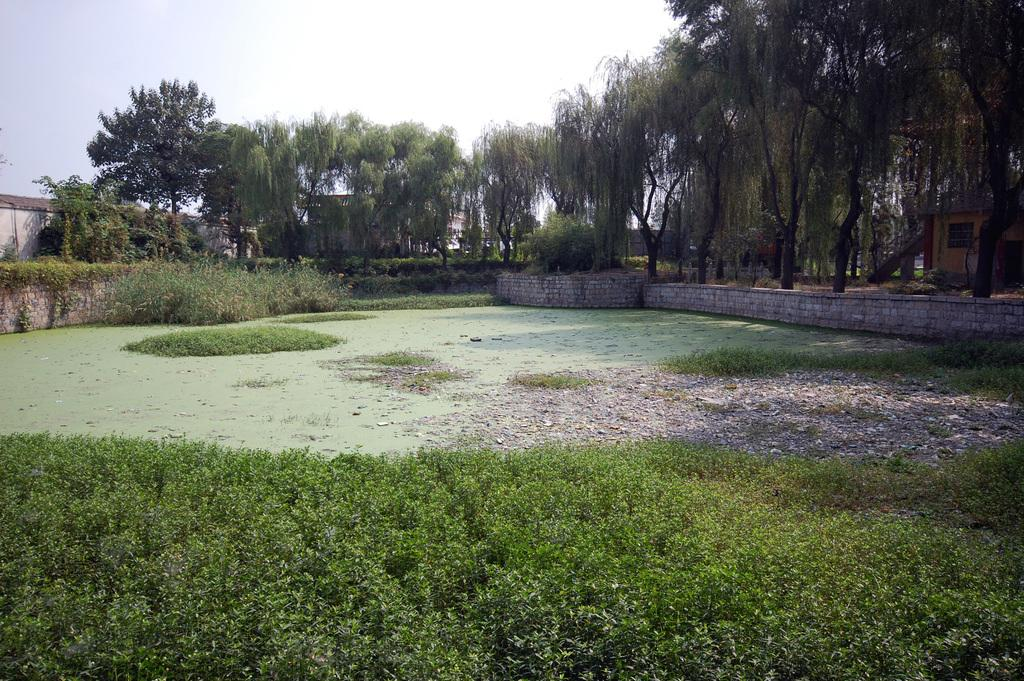What type of vegetation is in the front of the image? There is grass in the front of the image. What is located in the center of the image? There is water in the center of the image. What can be seen in the background of the image? There are trees in the background of the image. Where is the house located in the image? The house is on the right side of the image. What is on the left side of the image? There is a wall on the left side of the image. How many pieces of lumber are stacked against the wall in the image? There is no lumber present in the image; it features grass, water, trees, a house, and a wall. Is the person in the image sleeping or engaging in any health-related activities? There is no person present in the image, so it is not possible to determine if they are sleeping or engaging in any health-related activities. 